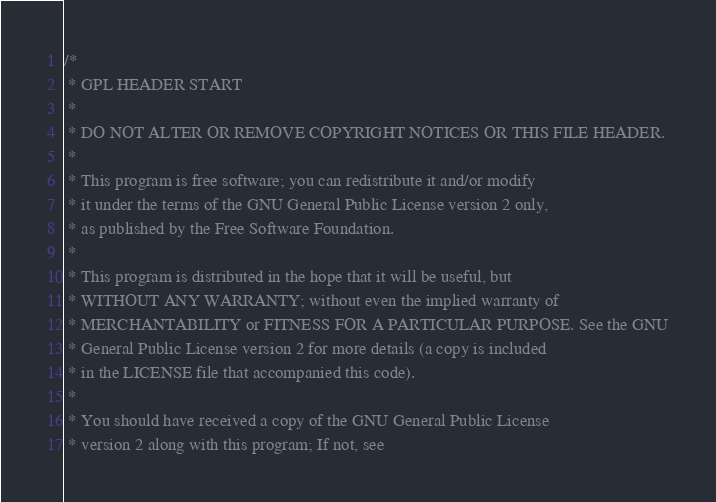Convert code to text. <code><loc_0><loc_0><loc_500><loc_500><_C_>/*
 * GPL HEADER START
 *
 * DO NOT ALTER OR REMOVE COPYRIGHT NOTICES OR THIS FILE HEADER.
 *
 * This program is free software; you can redistribute it and/or modify
 * it under the terms of the GNU General Public License version 2 only,
 * as published by the Free Software Foundation.
 *
 * This program is distributed in the hope that it will be useful, but
 * WITHOUT ANY WARRANTY; without even the implied warranty of
 * MERCHANTABILITY or FITNESS FOR A PARTICULAR PURPOSE. See the GNU
 * General Public License version 2 for more details (a copy is included
 * in the LICENSE file that accompanied this code).
 *
 * You should have received a copy of the GNU General Public License
 * version 2 along with this program; If not, see</code> 